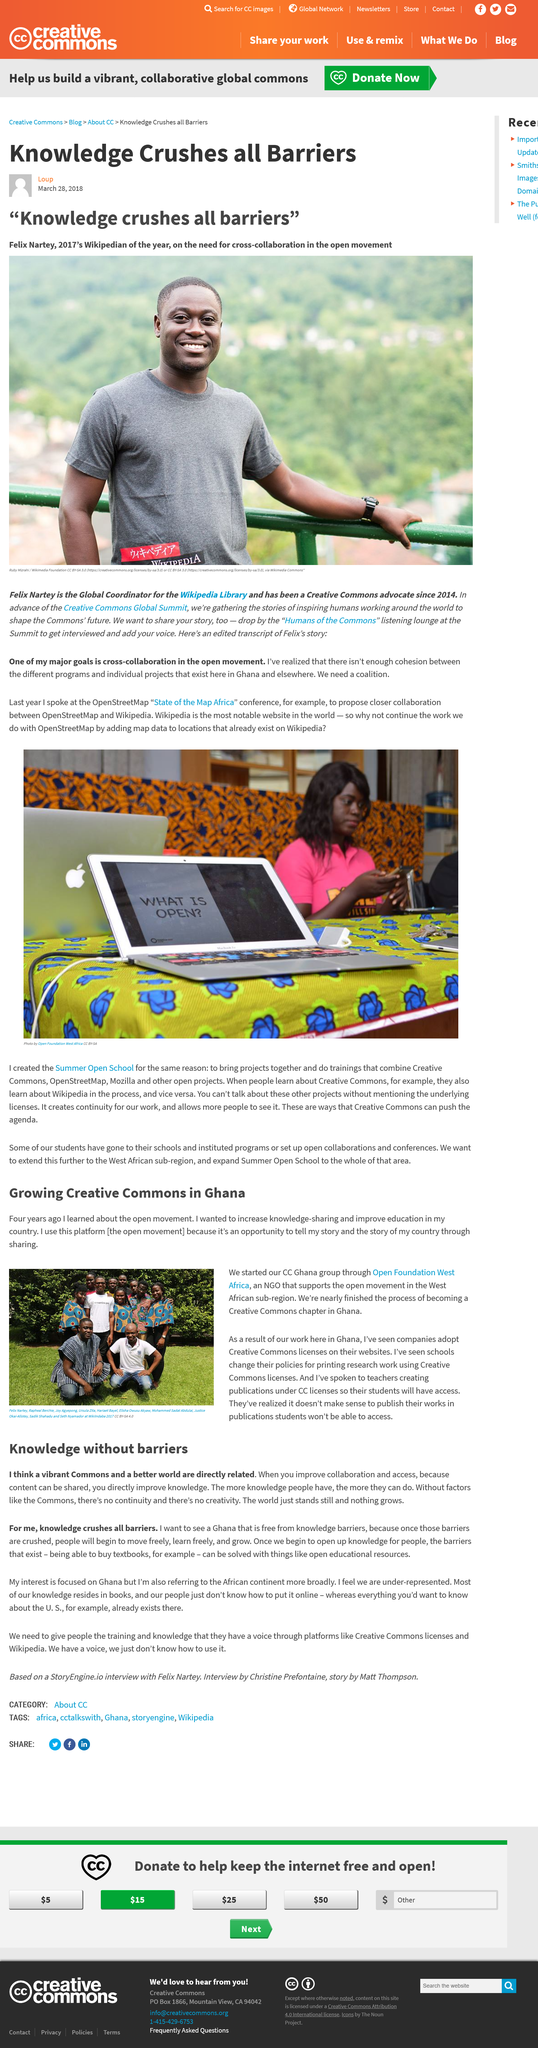Point out several critical features in this image. The narrator learned about the Open movement four years ago. Felix Nartey is based in Ghana. Felix Nartey is the 2017 Wikipedian of the year and the global coordinator for the Wikipedia library, as well as a dedicated advocate for Creative Commons since 2014. Open Foundation West Africa is an NGO that supports the open movement in the west African sub-region. The "Humans of the commons" listening lounge at the Creative Commons Global Summit provides a platform for individuals to share their voices and be heard. 